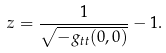Convert formula to latex. <formula><loc_0><loc_0><loc_500><loc_500>z = \frac { 1 } { \sqrt { - g _ { t t } ( 0 , 0 ) } } - 1 .</formula> 